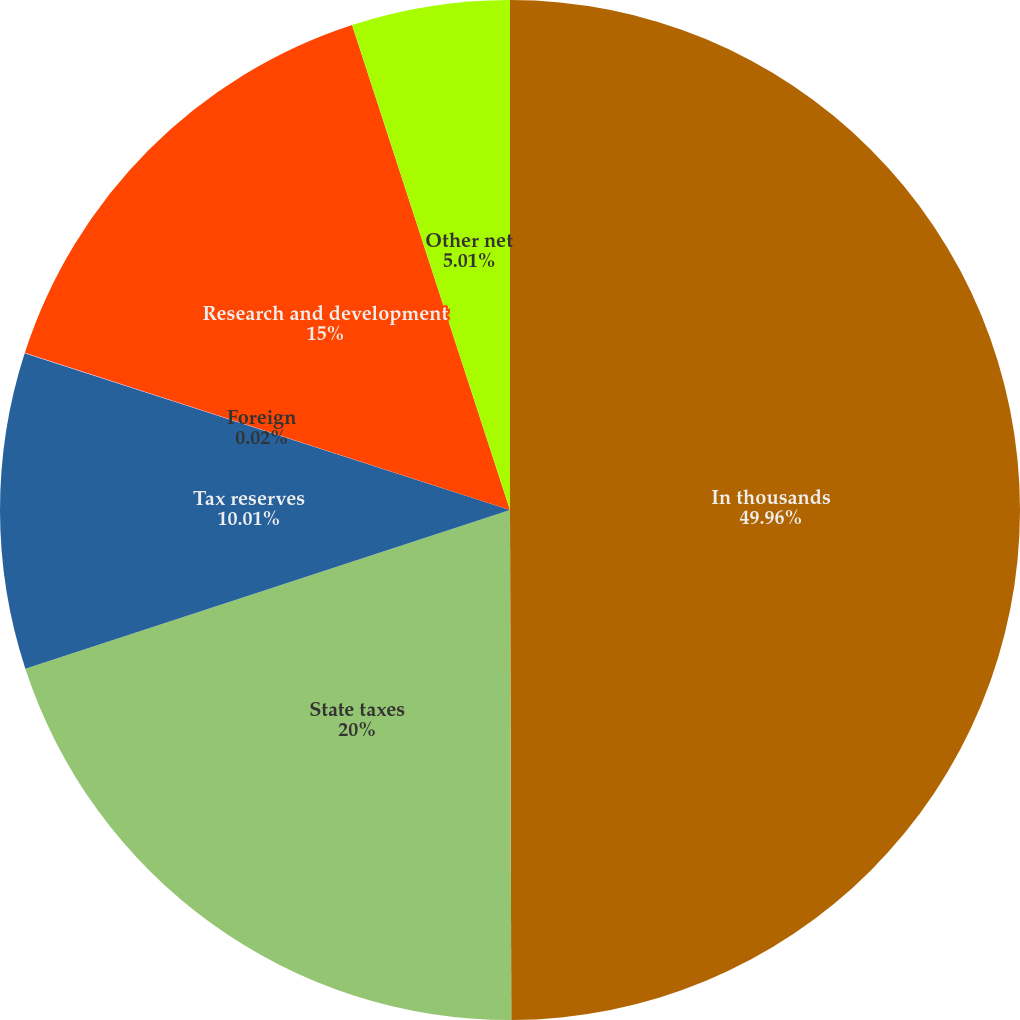Convert chart to OTSL. <chart><loc_0><loc_0><loc_500><loc_500><pie_chart><fcel>In thousands<fcel>State taxes<fcel>Tax reserves<fcel>Foreign<fcel>Research and development<fcel>Other net<nl><fcel>49.96%<fcel>20.0%<fcel>10.01%<fcel>0.02%<fcel>15.0%<fcel>5.01%<nl></chart> 